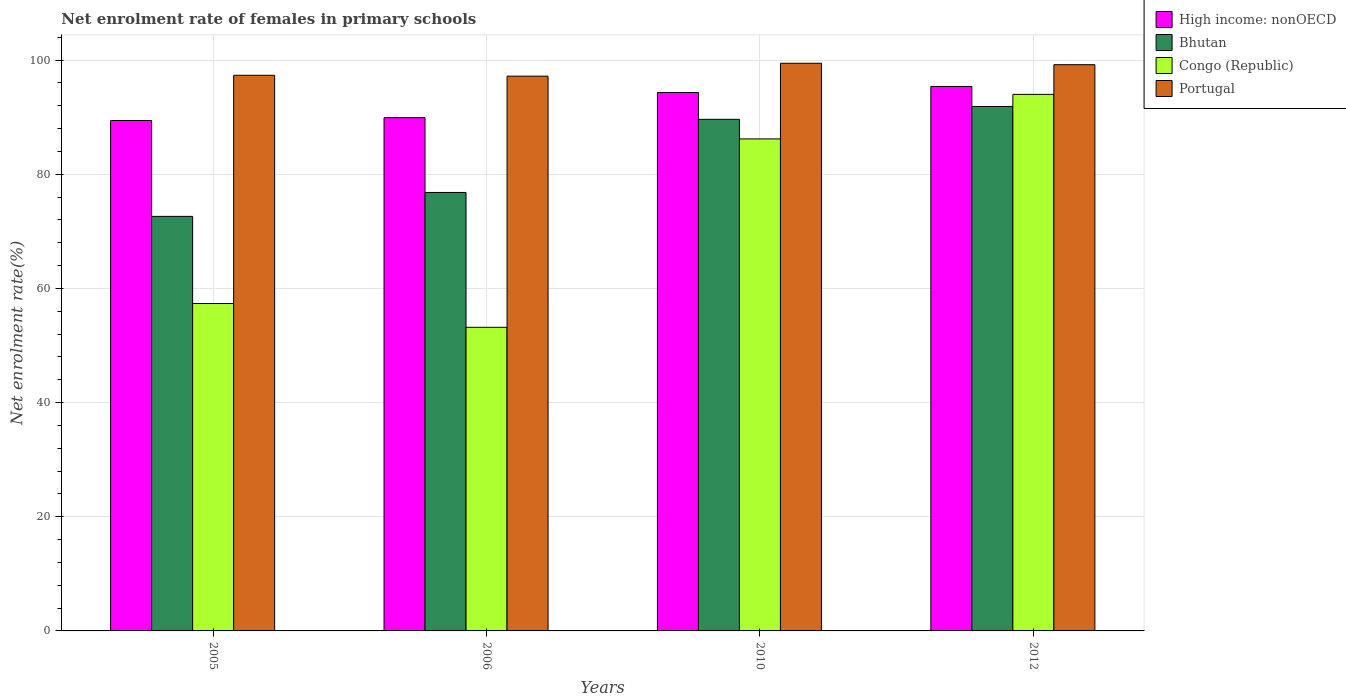How many groups of bars are there?
Give a very brief answer. 4. Are the number of bars per tick equal to the number of legend labels?
Keep it short and to the point. Yes. How many bars are there on the 1st tick from the left?
Provide a short and direct response. 4. How many bars are there on the 3rd tick from the right?
Your answer should be very brief. 4. What is the net enrolment rate of females in primary schools in High income: nonOECD in 2005?
Your answer should be very brief. 89.42. Across all years, what is the maximum net enrolment rate of females in primary schools in Bhutan?
Ensure brevity in your answer.  91.89. Across all years, what is the minimum net enrolment rate of females in primary schools in Congo (Republic)?
Ensure brevity in your answer.  53.2. In which year was the net enrolment rate of females in primary schools in Congo (Republic) minimum?
Make the answer very short. 2006. What is the total net enrolment rate of females in primary schools in Bhutan in the graph?
Offer a terse response. 330.97. What is the difference between the net enrolment rate of females in primary schools in Congo (Republic) in 2010 and that in 2012?
Offer a very short reply. -7.8. What is the difference between the net enrolment rate of females in primary schools in Bhutan in 2012 and the net enrolment rate of females in primary schools in Congo (Republic) in 2006?
Offer a terse response. 38.69. What is the average net enrolment rate of females in primary schools in Portugal per year?
Give a very brief answer. 98.3. In the year 2012, what is the difference between the net enrolment rate of females in primary schools in High income: nonOECD and net enrolment rate of females in primary schools in Portugal?
Your answer should be very brief. -3.82. What is the ratio of the net enrolment rate of females in primary schools in High income: nonOECD in 2005 to that in 2006?
Make the answer very short. 0.99. Is the net enrolment rate of females in primary schools in Congo (Republic) in 2005 less than that in 2006?
Provide a short and direct response. No. What is the difference between the highest and the second highest net enrolment rate of females in primary schools in Portugal?
Your answer should be compact. 0.25. What is the difference between the highest and the lowest net enrolment rate of females in primary schools in Bhutan?
Your answer should be very brief. 19.26. In how many years, is the net enrolment rate of females in primary schools in Congo (Republic) greater than the average net enrolment rate of females in primary schools in Congo (Republic) taken over all years?
Keep it short and to the point. 2. Is the sum of the net enrolment rate of females in primary schools in Portugal in 2006 and 2012 greater than the maximum net enrolment rate of females in primary schools in Bhutan across all years?
Your response must be concise. Yes. What does the 4th bar from the left in 2010 represents?
Provide a short and direct response. Portugal. How many years are there in the graph?
Offer a terse response. 4. Does the graph contain grids?
Your answer should be compact. Yes. Where does the legend appear in the graph?
Your answer should be compact. Top right. How many legend labels are there?
Provide a succinct answer. 4. What is the title of the graph?
Provide a short and direct response. Net enrolment rate of females in primary schools. What is the label or title of the Y-axis?
Make the answer very short. Net enrolment rate(%). What is the Net enrolment rate(%) of High income: nonOECD in 2005?
Provide a short and direct response. 89.42. What is the Net enrolment rate(%) of Bhutan in 2005?
Your answer should be very brief. 72.63. What is the Net enrolment rate(%) in Congo (Republic) in 2005?
Offer a very short reply. 57.36. What is the Net enrolment rate(%) in Portugal in 2005?
Keep it short and to the point. 97.35. What is the Net enrolment rate(%) of High income: nonOECD in 2006?
Ensure brevity in your answer.  89.92. What is the Net enrolment rate(%) of Bhutan in 2006?
Provide a short and direct response. 76.82. What is the Net enrolment rate(%) of Congo (Republic) in 2006?
Offer a terse response. 53.2. What is the Net enrolment rate(%) of Portugal in 2006?
Offer a very short reply. 97.2. What is the Net enrolment rate(%) of High income: nonOECD in 2010?
Provide a short and direct response. 94.33. What is the Net enrolment rate(%) in Bhutan in 2010?
Your answer should be very brief. 89.63. What is the Net enrolment rate(%) of Congo (Republic) in 2010?
Offer a terse response. 86.2. What is the Net enrolment rate(%) of Portugal in 2010?
Provide a succinct answer. 99.46. What is the Net enrolment rate(%) of High income: nonOECD in 2012?
Make the answer very short. 95.39. What is the Net enrolment rate(%) of Bhutan in 2012?
Offer a terse response. 91.89. What is the Net enrolment rate(%) of Congo (Republic) in 2012?
Offer a terse response. 94.01. What is the Net enrolment rate(%) in Portugal in 2012?
Give a very brief answer. 99.21. Across all years, what is the maximum Net enrolment rate(%) in High income: nonOECD?
Ensure brevity in your answer.  95.39. Across all years, what is the maximum Net enrolment rate(%) in Bhutan?
Give a very brief answer. 91.89. Across all years, what is the maximum Net enrolment rate(%) of Congo (Republic)?
Make the answer very short. 94.01. Across all years, what is the maximum Net enrolment rate(%) of Portugal?
Your response must be concise. 99.46. Across all years, what is the minimum Net enrolment rate(%) in High income: nonOECD?
Offer a very short reply. 89.42. Across all years, what is the minimum Net enrolment rate(%) in Bhutan?
Offer a very short reply. 72.63. Across all years, what is the minimum Net enrolment rate(%) in Congo (Republic)?
Provide a short and direct response. 53.2. Across all years, what is the minimum Net enrolment rate(%) of Portugal?
Provide a short and direct response. 97.2. What is the total Net enrolment rate(%) of High income: nonOECD in the graph?
Give a very brief answer. 369.06. What is the total Net enrolment rate(%) of Bhutan in the graph?
Offer a terse response. 330.97. What is the total Net enrolment rate(%) of Congo (Republic) in the graph?
Your response must be concise. 290.77. What is the total Net enrolment rate(%) in Portugal in the graph?
Provide a short and direct response. 393.21. What is the difference between the Net enrolment rate(%) in High income: nonOECD in 2005 and that in 2006?
Give a very brief answer. -0.5. What is the difference between the Net enrolment rate(%) in Bhutan in 2005 and that in 2006?
Provide a succinct answer. -4.19. What is the difference between the Net enrolment rate(%) of Congo (Republic) in 2005 and that in 2006?
Keep it short and to the point. 4.16. What is the difference between the Net enrolment rate(%) in Portugal in 2005 and that in 2006?
Your answer should be very brief. 0.15. What is the difference between the Net enrolment rate(%) of High income: nonOECD in 2005 and that in 2010?
Your answer should be very brief. -4.91. What is the difference between the Net enrolment rate(%) of Bhutan in 2005 and that in 2010?
Your answer should be very brief. -17. What is the difference between the Net enrolment rate(%) in Congo (Republic) in 2005 and that in 2010?
Offer a terse response. -28.84. What is the difference between the Net enrolment rate(%) of Portugal in 2005 and that in 2010?
Provide a short and direct response. -2.11. What is the difference between the Net enrolment rate(%) of High income: nonOECD in 2005 and that in 2012?
Keep it short and to the point. -5.96. What is the difference between the Net enrolment rate(%) of Bhutan in 2005 and that in 2012?
Offer a very short reply. -19.26. What is the difference between the Net enrolment rate(%) in Congo (Republic) in 2005 and that in 2012?
Make the answer very short. -36.64. What is the difference between the Net enrolment rate(%) of Portugal in 2005 and that in 2012?
Keep it short and to the point. -1.86. What is the difference between the Net enrolment rate(%) in High income: nonOECD in 2006 and that in 2010?
Offer a very short reply. -4.41. What is the difference between the Net enrolment rate(%) of Bhutan in 2006 and that in 2010?
Your answer should be compact. -12.81. What is the difference between the Net enrolment rate(%) in Congo (Republic) in 2006 and that in 2010?
Give a very brief answer. -33. What is the difference between the Net enrolment rate(%) of Portugal in 2006 and that in 2010?
Keep it short and to the point. -2.26. What is the difference between the Net enrolment rate(%) in High income: nonOECD in 2006 and that in 2012?
Your answer should be very brief. -5.47. What is the difference between the Net enrolment rate(%) in Bhutan in 2006 and that in 2012?
Make the answer very short. -15.07. What is the difference between the Net enrolment rate(%) in Congo (Republic) in 2006 and that in 2012?
Provide a succinct answer. -40.81. What is the difference between the Net enrolment rate(%) of Portugal in 2006 and that in 2012?
Offer a very short reply. -2.01. What is the difference between the Net enrolment rate(%) of High income: nonOECD in 2010 and that in 2012?
Ensure brevity in your answer.  -1.06. What is the difference between the Net enrolment rate(%) in Bhutan in 2010 and that in 2012?
Provide a short and direct response. -2.26. What is the difference between the Net enrolment rate(%) of Congo (Republic) in 2010 and that in 2012?
Give a very brief answer. -7.8. What is the difference between the Net enrolment rate(%) of Portugal in 2010 and that in 2012?
Make the answer very short. 0.25. What is the difference between the Net enrolment rate(%) of High income: nonOECD in 2005 and the Net enrolment rate(%) of Bhutan in 2006?
Ensure brevity in your answer.  12.6. What is the difference between the Net enrolment rate(%) in High income: nonOECD in 2005 and the Net enrolment rate(%) in Congo (Republic) in 2006?
Make the answer very short. 36.23. What is the difference between the Net enrolment rate(%) of High income: nonOECD in 2005 and the Net enrolment rate(%) of Portugal in 2006?
Offer a very short reply. -7.78. What is the difference between the Net enrolment rate(%) in Bhutan in 2005 and the Net enrolment rate(%) in Congo (Republic) in 2006?
Offer a very short reply. 19.43. What is the difference between the Net enrolment rate(%) in Bhutan in 2005 and the Net enrolment rate(%) in Portugal in 2006?
Keep it short and to the point. -24.57. What is the difference between the Net enrolment rate(%) of Congo (Republic) in 2005 and the Net enrolment rate(%) of Portugal in 2006?
Ensure brevity in your answer.  -39.84. What is the difference between the Net enrolment rate(%) of High income: nonOECD in 2005 and the Net enrolment rate(%) of Bhutan in 2010?
Your response must be concise. -0.21. What is the difference between the Net enrolment rate(%) of High income: nonOECD in 2005 and the Net enrolment rate(%) of Congo (Republic) in 2010?
Your answer should be very brief. 3.22. What is the difference between the Net enrolment rate(%) in High income: nonOECD in 2005 and the Net enrolment rate(%) in Portugal in 2010?
Your answer should be compact. -10.03. What is the difference between the Net enrolment rate(%) in Bhutan in 2005 and the Net enrolment rate(%) in Congo (Republic) in 2010?
Your answer should be very brief. -13.57. What is the difference between the Net enrolment rate(%) in Bhutan in 2005 and the Net enrolment rate(%) in Portugal in 2010?
Make the answer very short. -26.83. What is the difference between the Net enrolment rate(%) in Congo (Republic) in 2005 and the Net enrolment rate(%) in Portugal in 2010?
Give a very brief answer. -42.1. What is the difference between the Net enrolment rate(%) of High income: nonOECD in 2005 and the Net enrolment rate(%) of Bhutan in 2012?
Give a very brief answer. -2.47. What is the difference between the Net enrolment rate(%) in High income: nonOECD in 2005 and the Net enrolment rate(%) in Congo (Republic) in 2012?
Your answer should be compact. -4.58. What is the difference between the Net enrolment rate(%) of High income: nonOECD in 2005 and the Net enrolment rate(%) of Portugal in 2012?
Offer a very short reply. -9.78. What is the difference between the Net enrolment rate(%) in Bhutan in 2005 and the Net enrolment rate(%) in Congo (Republic) in 2012?
Offer a terse response. -21.38. What is the difference between the Net enrolment rate(%) of Bhutan in 2005 and the Net enrolment rate(%) of Portugal in 2012?
Provide a short and direct response. -26.58. What is the difference between the Net enrolment rate(%) in Congo (Republic) in 2005 and the Net enrolment rate(%) in Portugal in 2012?
Make the answer very short. -41.84. What is the difference between the Net enrolment rate(%) of High income: nonOECD in 2006 and the Net enrolment rate(%) of Bhutan in 2010?
Provide a succinct answer. 0.29. What is the difference between the Net enrolment rate(%) in High income: nonOECD in 2006 and the Net enrolment rate(%) in Congo (Republic) in 2010?
Give a very brief answer. 3.72. What is the difference between the Net enrolment rate(%) in High income: nonOECD in 2006 and the Net enrolment rate(%) in Portugal in 2010?
Offer a very short reply. -9.54. What is the difference between the Net enrolment rate(%) of Bhutan in 2006 and the Net enrolment rate(%) of Congo (Republic) in 2010?
Your response must be concise. -9.38. What is the difference between the Net enrolment rate(%) in Bhutan in 2006 and the Net enrolment rate(%) in Portugal in 2010?
Offer a very short reply. -22.64. What is the difference between the Net enrolment rate(%) in Congo (Republic) in 2006 and the Net enrolment rate(%) in Portugal in 2010?
Keep it short and to the point. -46.26. What is the difference between the Net enrolment rate(%) in High income: nonOECD in 2006 and the Net enrolment rate(%) in Bhutan in 2012?
Your answer should be compact. -1.97. What is the difference between the Net enrolment rate(%) in High income: nonOECD in 2006 and the Net enrolment rate(%) in Congo (Republic) in 2012?
Keep it short and to the point. -4.08. What is the difference between the Net enrolment rate(%) in High income: nonOECD in 2006 and the Net enrolment rate(%) in Portugal in 2012?
Ensure brevity in your answer.  -9.28. What is the difference between the Net enrolment rate(%) in Bhutan in 2006 and the Net enrolment rate(%) in Congo (Republic) in 2012?
Provide a short and direct response. -17.19. What is the difference between the Net enrolment rate(%) of Bhutan in 2006 and the Net enrolment rate(%) of Portugal in 2012?
Your answer should be very brief. -22.39. What is the difference between the Net enrolment rate(%) of Congo (Republic) in 2006 and the Net enrolment rate(%) of Portugal in 2012?
Make the answer very short. -46.01. What is the difference between the Net enrolment rate(%) in High income: nonOECD in 2010 and the Net enrolment rate(%) in Bhutan in 2012?
Offer a very short reply. 2.44. What is the difference between the Net enrolment rate(%) in High income: nonOECD in 2010 and the Net enrolment rate(%) in Congo (Republic) in 2012?
Make the answer very short. 0.32. What is the difference between the Net enrolment rate(%) in High income: nonOECD in 2010 and the Net enrolment rate(%) in Portugal in 2012?
Ensure brevity in your answer.  -4.88. What is the difference between the Net enrolment rate(%) in Bhutan in 2010 and the Net enrolment rate(%) in Congo (Republic) in 2012?
Offer a terse response. -4.37. What is the difference between the Net enrolment rate(%) of Bhutan in 2010 and the Net enrolment rate(%) of Portugal in 2012?
Your answer should be very brief. -9.57. What is the difference between the Net enrolment rate(%) in Congo (Republic) in 2010 and the Net enrolment rate(%) in Portugal in 2012?
Give a very brief answer. -13. What is the average Net enrolment rate(%) of High income: nonOECD per year?
Your answer should be very brief. 92.27. What is the average Net enrolment rate(%) in Bhutan per year?
Your answer should be compact. 82.74. What is the average Net enrolment rate(%) of Congo (Republic) per year?
Your response must be concise. 72.69. What is the average Net enrolment rate(%) in Portugal per year?
Offer a very short reply. 98.3. In the year 2005, what is the difference between the Net enrolment rate(%) of High income: nonOECD and Net enrolment rate(%) of Bhutan?
Give a very brief answer. 16.79. In the year 2005, what is the difference between the Net enrolment rate(%) of High income: nonOECD and Net enrolment rate(%) of Congo (Republic)?
Provide a succinct answer. 32.06. In the year 2005, what is the difference between the Net enrolment rate(%) of High income: nonOECD and Net enrolment rate(%) of Portugal?
Offer a very short reply. -7.93. In the year 2005, what is the difference between the Net enrolment rate(%) of Bhutan and Net enrolment rate(%) of Congo (Republic)?
Your answer should be compact. 15.27. In the year 2005, what is the difference between the Net enrolment rate(%) of Bhutan and Net enrolment rate(%) of Portugal?
Your response must be concise. -24.72. In the year 2005, what is the difference between the Net enrolment rate(%) of Congo (Republic) and Net enrolment rate(%) of Portugal?
Your answer should be very brief. -39.99. In the year 2006, what is the difference between the Net enrolment rate(%) of High income: nonOECD and Net enrolment rate(%) of Bhutan?
Keep it short and to the point. 13.1. In the year 2006, what is the difference between the Net enrolment rate(%) of High income: nonOECD and Net enrolment rate(%) of Congo (Republic)?
Your answer should be compact. 36.72. In the year 2006, what is the difference between the Net enrolment rate(%) in High income: nonOECD and Net enrolment rate(%) in Portugal?
Keep it short and to the point. -7.28. In the year 2006, what is the difference between the Net enrolment rate(%) in Bhutan and Net enrolment rate(%) in Congo (Republic)?
Your response must be concise. 23.62. In the year 2006, what is the difference between the Net enrolment rate(%) of Bhutan and Net enrolment rate(%) of Portugal?
Give a very brief answer. -20.38. In the year 2006, what is the difference between the Net enrolment rate(%) in Congo (Republic) and Net enrolment rate(%) in Portugal?
Give a very brief answer. -44. In the year 2010, what is the difference between the Net enrolment rate(%) of High income: nonOECD and Net enrolment rate(%) of Bhutan?
Offer a terse response. 4.7. In the year 2010, what is the difference between the Net enrolment rate(%) in High income: nonOECD and Net enrolment rate(%) in Congo (Republic)?
Offer a terse response. 8.13. In the year 2010, what is the difference between the Net enrolment rate(%) in High income: nonOECD and Net enrolment rate(%) in Portugal?
Keep it short and to the point. -5.13. In the year 2010, what is the difference between the Net enrolment rate(%) in Bhutan and Net enrolment rate(%) in Congo (Republic)?
Your response must be concise. 3.43. In the year 2010, what is the difference between the Net enrolment rate(%) in Bhutan and Net enrolment rate(%) in Portugal?
Provide a succinct answer. -9.82. In the year 2010, what is the difference between the Net enrolment rate(%) of Congo (Republic) and Net enrolment rate(%) of Portugal?
Your response must be concise. -13.25. In the year 2012, what is the difference between the Net enrolment rate(%) of High income: nonOECD and Net enrolment rate(%) of Bhutan?
Provide a short and direct response. 3.5. In the year 2012, what is the difference between the Net enrolment rate(%) in High income: nonOECD and Net enrolment rate(%) in Congo (Republic)?
Offer a terse response. 1.38. In the year 2012, what is the difference between the Net enrolment rate(%) in High income: nonOECD and Net enrolment rate(%) in Portugal?
Ensure brevity in your answer.  -3.82. In the year 2012, what is the difference between the Net enrolment rate(%) in Bhutan and Net enrolment rate(%) in Congo (Republic)?
Offer a terse response. -2.12. In the year 2012, what is the difference between the Net enrolment rate(%) of Bhutan and Net enrolment rate(%) of Portugal?
Make the answer very short. -7.32. In the year 2012, what is the difference between the Net enrolment rate(%) of Congo (Republic) and Net enrolment rate(%) of Portugal?
Your response must be concise. -5.2. What is the ratio of the Net enrolment rate(%) in Bhutan in 2005 to that in 2006?
Provide a short and direct response. 0.95. What is the ratio of the Net enrolment rate(%) in Congo (Republic) in 2005 to that in 2006?
Your answer should be compact. 1.08. What is the ratio of the Net enrolment rate(%) in High income: nonOECD in 2005 to that in 2010?
Provide a succinct answer. 0.95. What is the ratio of the Net enrolment rate(%) of Bhutan in 2005 to that in 2010?
Give a very brief answer. 0.81. What is the ratio of the Net enrolment rate(%) in Congo (Republic) in 2005 to that in 2010?
Your response must be concise. 0.67. What is the ratio of the Net enrolment rate(%) of Portugal in 2005 to that in 2010?
Your answer should be compact. 0.98. What is the ratio of the Net enrolment rate(%) of High income: nonOECD in 2005 to that in 2012?
Offer a very short reply. 0.94. What is the ratio of the Net enrolment rate(%) in Bhutan in 2005 to that in 2012?
Offer a terse response. 0.79. What is the ratio of the Net enrolment rate(%) of Congo (Republic) in 2005 to that in 2012?
Ensure brevity in your answer.  0.61. What is the ratio of the Net enrolment rate(%) of Portugal in 2005 to that in 2012?
Your answer should be compact. 0.98. What is the ratio of the Net enrolment rate(%) in High income: nonOECD in 2006 to that in 2010?
Your response must be concise. 0.95. What is the ratio of the Net enrolment rate(%) of Bhutan in 2006 to that in 2010?
Provide a short and direct response. 0.86. What is the ratio of the Net enrolment rate(%) in Congo (Republic) in 2006 to that in 2010?
Give a very brief answer. 0.62. What is the ratio of the Net enrolment rate(%) of Portugal in 2006 to that in 2010?
Your response must be concise. 0.98. What is the ratio of the Net enrolment rate(%) of High income: nonOECD in 2006 to that in 2012?
Make the answer very short. 0.94. What is the ratio of the Net enrolment rate(%) of Bhutan in 2006 to that in 2012?
Your answer should be compact. 0.84. What is the ratio of the Net enrolment rate(%) in Congo (Republic) in 2006 to that in 2012?
Provide a short and direct response. 0.57. What is the ratio of the Net enrolment rate(%) of Portugal in 2006 to that in 2012?
Give a very brief answer. 0.98. What is the ratio of the Net enrolment rate(%) of High income: nonOECD in 2010 to that in 2012?
Your answer should be compact. 0.99. What is the ratio of the Net enrolment rate(%) of Bhutan in 2010 to that in 2012?
Offer a very short reply. 0.98. What is the ratio of the Net enrolment rate(%) in Congo (Republic) in 2010 to that in 2012?
Give a very brief answer. 0.92. What is the ratio of the Net enrolment rate(%) in Portugal in 2010 to that in 2012?
Your answer should be compact. 1. What is the difference between the highest and the second highest Net enrolment rate(%) in High income: nonOECD?
Your answer should be very brief. 1.06. What is the difference between the highest and the second highest Net enrolment rate(%) of Bhutan?
Offer a very short reply. 2.26. What is the difference between the highest and the second highest Net enrolment rate(%) of Congo (Republic)?
Make the answer very short. 7.8. What is the difference between the highest and the second highest Net enrolment rate(%) of Portugal?
Give a very brief answer. 0.25. What is the difference between the highest and the lowest Net enrolment rate(%) of High income: nonOECD?
Keep it short and to the point. 5.96. What is the difference between the highest and the lowest Net enrolment rate(%) in Bhutan?
Keep it short and to the point. 19.26. What is the difference between the highest and the lowest Net enrolment rate(%) of Congo (Republic)?
Keep it short and to the point. 40.81. What is the difference between the highest and the lowest Net enrolment rate(%) of Portugal?
Give a very brief answer. 2.26. 